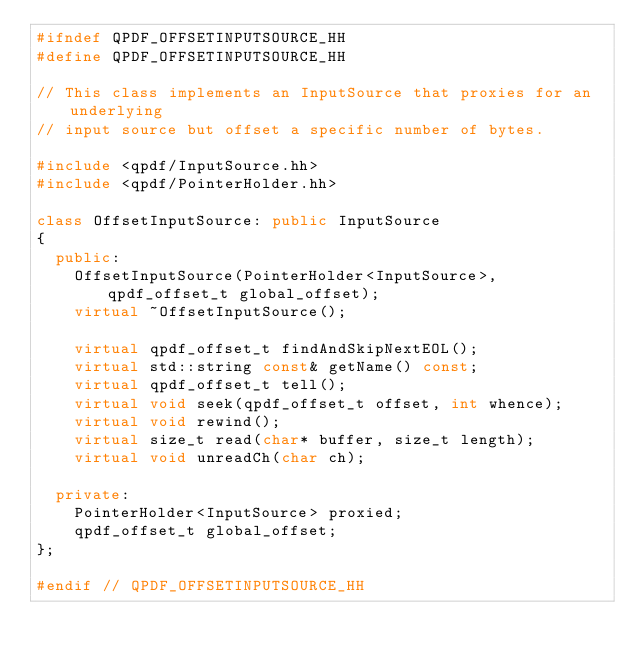<code> <loc_0><loc_0><loc_500><loc_500><_C++_>#ifndef QPDF_OFFSETINPUTSOURCE_HH
#define QPDF_OFFSETINPUTSOURCE_HH

// This class implements an InputSource that proxies for an underlying
// input source but offset a specific number of bytes.

#include <qpdf/InputSource.hh>
#include <qpdf/PointerHolder.hh>

class OffsetInputSource: public InputSource
{
  public:
    OffsetInputSource(PointerHolder<InputSource>, qpdf_offset_t global_offset);
    virtual ~OffsetInputSource();

    virtual qpdf_offset_t findAndSkipNextEOL();
    virtual std::string const& getName() const;
    virtual qpdf_offset_t tell();
    virtual void seek(qpdf_offset_t offset, int whence);
    virtual void rewind();
    virtual size_t read(char* buffer, size_t length);
    virtual void unreadCh(char ch);

  private:
    PointerHolder<InputSource> proxied;
    qpdf_offset_t global_offset;
};

#endif // QPDF_OFFSETINPUTSOURCE_HH
</code> 